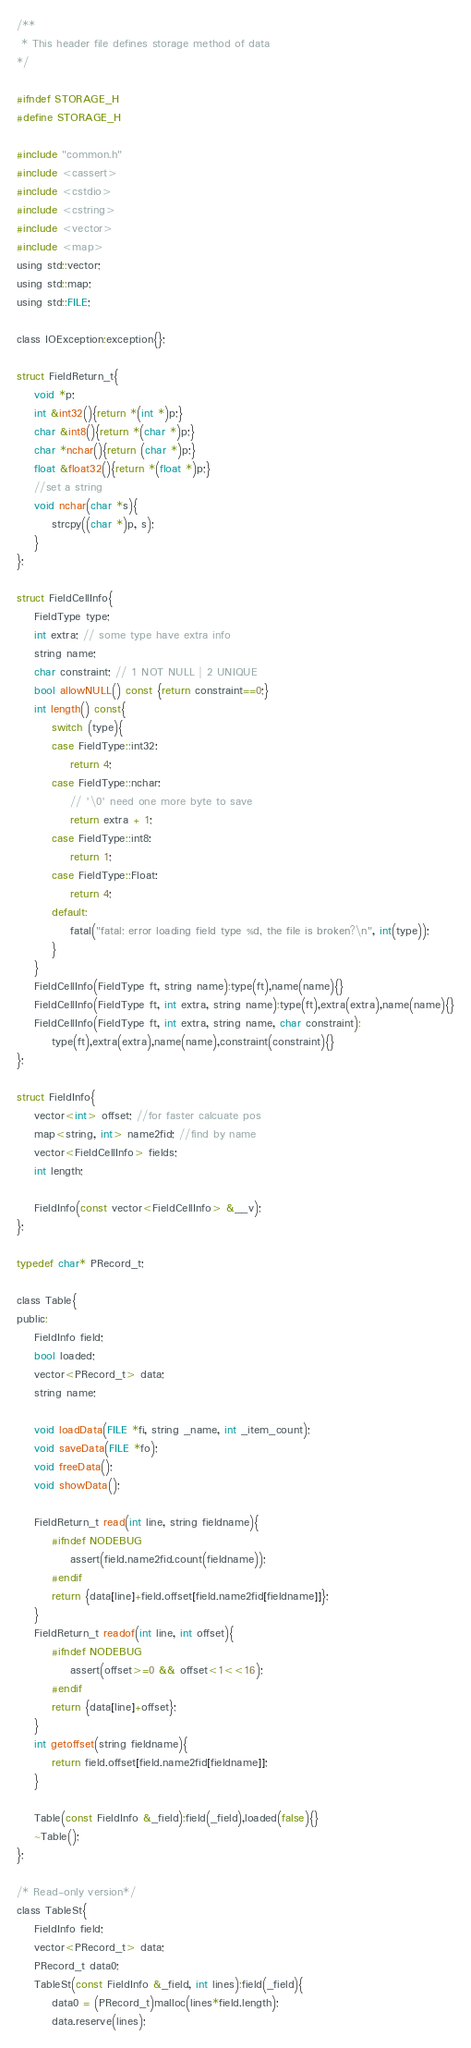<code> <loc_0><loc_0><loc_500><loc_500><_C_>/**
 * This header file defines storage method of data
*/

#ifndef STORAGE_H
#define STORAGE_H

#include "common.h"
#include <cassert>
#include <cstdio>
#include <cstring>
#include <vector>
#include <map>
using std::vector;
using std::map;
using std::FILE;

class IOException:exception{};

struct FieldReturn_t{
    void *p;
    int &int32(){return *(int *)p;}
    char &int8(){return *(char *)p;}
    char *nchar(){return (char *)p;}
    float &float32(){return *(float *)p;}
    //set a string
    void nchar(char *s){
        strcpy((char *)p, s);
    }
};

struct FieldCellInfo{
    FieldType type;
    int extra; // some type have extra info
    string name;
    char constraint; // 1 NOT NULL | 2 UNIQUE
    bool allowNULL() const {return constraint==0;}
    int length() const{
        switch (type){
        case FieldType::int32:
            return 4;
        case FieldType::nchar:
            // '\0' need one more byte to save
            return extra + 1;
        case FieldType::int8:
            return 1;
        case FieldType::Float:
            return 4;
        default:
            fatal("fatal: error loading field type %d, the file is broken?\n", int(type));
        }
    }
    FieldCellInfo(FieldType ft, string name):type(ft),name(name){}
    FieldCellInfo(FieldType ft, int extra, string name):type(ft),extra(extra),name(name){}
    FieldCellInfo(FieldType ft, int extra, string name, char constraint):
        type(ft),extra(extra),name(name),constraint(constraint){}
};

struct FieldInfo{
    vector<int> offset; //for faster calcuate pos
    map<string, int> name2fid; //find by name
    vector<FieldCellInfo> fields;
    int length;

    FieldInfo(const vector<FieldCellInfo> &__v);
};

typedef char* PRecord_t;

class Table{
public:
    FieldInfo field;
    bool loaded;
    vector<PRecord_t> data;
    string name;
    
    void loadData(FILE *fi, string _name, int _item_count);
    void saveData(FILE *fo);
    void freeData();
    void showData();
    
    FieldReturn_t read(int line, string fieldname){
        #ifndef NODEBUG
            assert(field.name2fid.count(fieldname));
        #endif
        return {data[line]+field.offset[field.name2fid[fieldname]]};
    }
    FieldReturn_t readof(int line, int offset){
        #ifndef NODEBUG
            assert(offset>=0 && offset<1<<16);
        #endif
        return {data[line]+offset};
    }
    int getoffset(string fieldname){
        return field.offset[field.name2fid[fieldname]];
    }

    Table(const FieldInfo &_field):field(_field),loaded(false){}
    ~Table();
};

/* Read-only version*/
class TableSt{
    FieldInfo field;
    vector<PRecord_t> data;
    PRecord_t data0;
    TableSt(const FieldInfo &_field, int lines):field(_field){
        data0 = (PRecord_t)malloc(lines*field.length);
        data.reserve(lines);</code> 